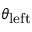Convert formula to latex. <formula><loc_0><loc_0><loc_500><loc_500>\theta _ { l e f t }</formula> 